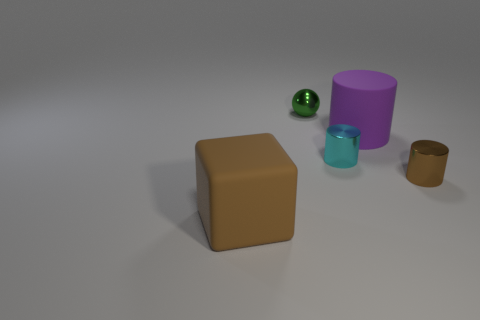Add 1 blocks. How many objects exist? 6 Subtract all balls. How many objects are left? 4 Add 2 tiny balls. How many tiny balls exist? 3 Subtract 0 gray cylinders. How many objects are left? 5 Subtract all brown shiny spheres. Subtract all purple things. How many objects are left? 4 Add 5 big brown objects. How many big brown objects are left? 6 